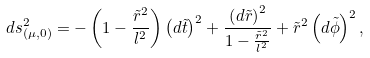Convert formula to latex. <formula><loc_0><loc_0><loc_500><loc_500>d s ^ { 2 } _ { ( \mu , 0 ) } = - \left ( 1 - \frac { \tilde { r } ^ { 2 } } { l ^ { 2 } } \right ) \left ( d \tilde { t } \right ) ^ { 2 } + \frac { \left ( d \tilde { r } \right ) ^ { 2 } } { 1 - \frac { \tilde { r } ^ { 2 } } { l ^ { 2 } } } + \tilde { r } ^ { 2 } \left ( d \tilde { \phi } \right ) ^ { 2 } ,</formula> 